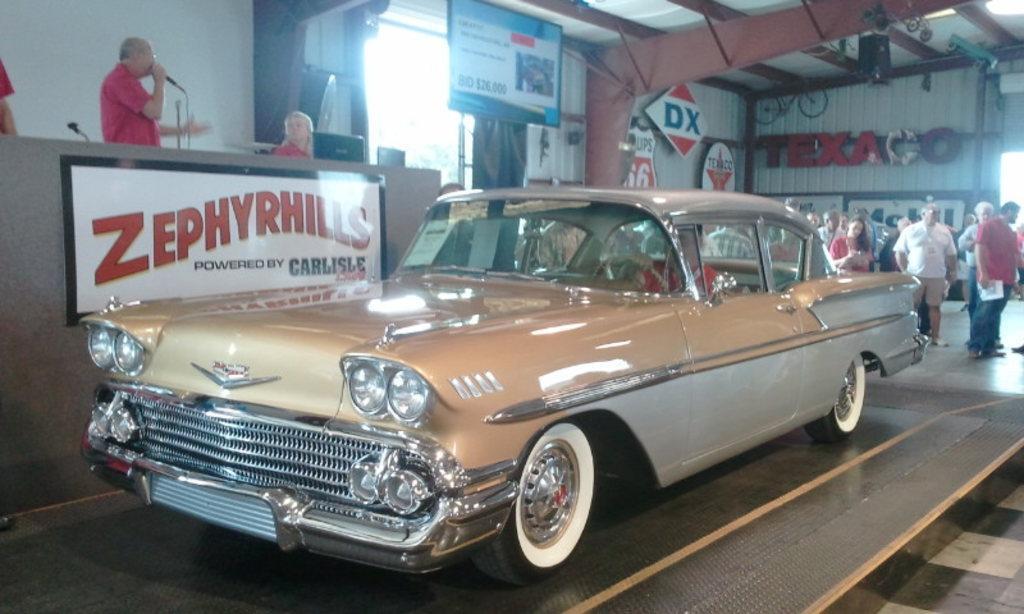Could you give a brief overview of what you see in this image? In this picture there is a car in the foreground. On the left side of the image there is a person with red t-shirt is standing and holding the microphone and there are two persons and there are devices and microphones on the table and there is a poster on the table. On the right side of the image there are group of people and at the top there are lights and at the back there are hoardings and there is a text on the wall. 